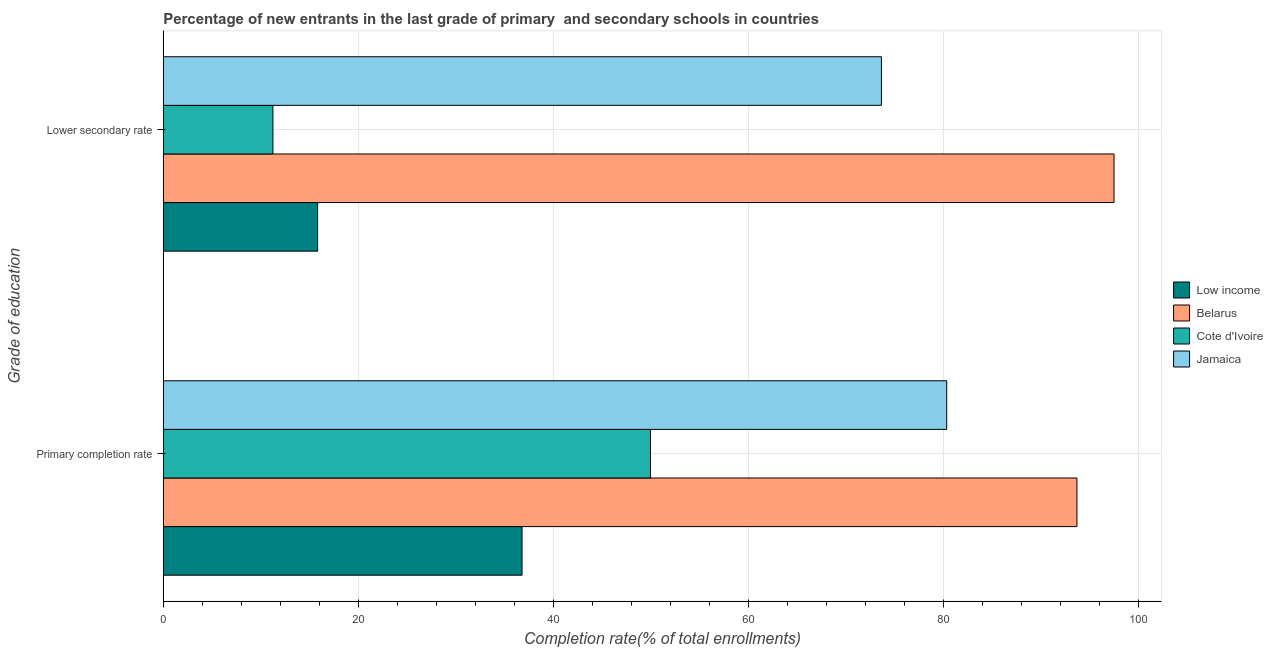Are the number of bars on each tick of the Y-axis equal?
Your response must be concise. Yes. How many bars are there on the 1st tick from the bottom?
Provide a succinct answer. 4. What is the label of the 1st group of bars from the top?
Your answer should be compact. Lower secondary rate. What is the completion rate in primary schools in Low income?
Keep it short and to the point. 36.77. Across all countries, what is the maximum completion rate in primary schools?
Your response must be concise. 93.64. Across all countries, what is the minimum completion rate in primary schools?
Keep it short and to the point. 36.77. In which country was the completion rate in primary schools maximum?
Your answer should be compact. Belarus. In which country was the completion rate in primary schools minimum?
Give a very brief answer. Low income. What is the total completion rate in primary schools in the graph?
Offer a terse response. 260.65. What is the difference between the completion rate in secondary schools in Belarus and that in Cote d'Ivoire?
Your answer should be compact. 86.21. What is the difference between the completion rate in primary schools in Cote d'Ivoire and the completion rate in secondary schools in Jamaica?
Provide a short and direct response. -23.67. What is the average completion rate in primary schools per country?
Give a very brief answer. 65.16. What is the difference between the completion rate in secondary schools and completion rate in primary schools in Jamaica?
Your answer should be very brief. -6.69. What is the ratio of the completion rate in primary schools in Jamaica to that in Low income?
Ensure brevity in your answer.  2.18. What does the 1st bar from the top in Primary completion rate represents?
Give a very brief answer. Jamaica. What does the 2nd bar from the bottom in Lower secondary rate represents?
Make the answer very short. Belarus. How many bars are there?
Your response must be concise. 8. Are all the bars in the graph horizontal?
Your answer should be compact. Yes. Are the values on the major ticks of X-axis written in scientific E-notation?
Offer a terse response. No. Does the graph contain grids?
Provide a short and direct response. Yes. Where does the legend appear in the graph?
Provide a succinct answer. Center right. How many legend labels are there?
Give a very brief answer. 4. What is the title of the graph?
Your answer should be compact. Percentage of new entrants in the last grade of primary  and secondary schools in countries. What is the label or title of the X-axis?
Ensure brevity in your answer.  Completion rate(% of total enrollments). What is the label or title of the Y-axis?
Keep it short and to the point. Grade of education. What is the Completion rate(% of total enrollments) of Low income in Primary completion rate?
Your answer should be very brief. 36.77. What is the Completion rate(% of total enrollments) of Belarus in Primary completion rate?
Your answer should be very brief. 93.64. What is the Completion rate(% of total enrollments) in Cote d'Ivoire in Primary completion rate?
Provide a succinct answer. 49.94. What is the Completion rate(% of total enrollments) of Jamaica in Primary completion rate?
Give a very brief answer. 80.3. What is the Completion rate(% of total enrollments) in Low income in Lower secondary rate?
Keep it short and to the point. 15.82. What is the Completion rate(% of total enrollments) in Belarus in Lower secondary rate?
Provide a succinct answer. 97.45. What is the Completion rate(% of total enrollments) of Cote d'Ivoire in Lower secondary rate?
Ensure brevity in your answer.  11.24. What is the Completion rate(% of total enrollments) in Jamaica in Lower secondary rate?
Provide a short and direct response. 73.6. Across all Grade of education, what is the maximum Completion rate(% of total enrollments) in Low income?
Keep it short and to the point. 36.77. Across all Grade of education, what is the maximum Completion rate(% of total enrollments) in Belarus?
Your answer should be very brief. 97.45. Across all Grade of education, what is the maximum Completion rate(% of total enrollments) in Cote d'Ivoire?
Ensure brevity in your answer.  49.94. Across all Grade of education, what is the maximum Completion rate(% of total enrollments) in Jamaica?
Your response must be concise. 80.3. Across all Grade of education, what is the minimum Completion rate(% of total enrollments) of Low income?
Your answer should be very brief. 15.82. Across all Grade of education, what is the minimum Completion rate(% of total enrollments) of Belarus?
Keep it short and to the point. 93.64. Across all Grade of education, what is the minimum Completion rate(% of total enrollments) in Cote d'Ivoire?
Your response must be concise. 11.24. Across all Grade of education, what is the minimum Completion rate(% of total enrollments) in Jamaica?
Ensure brevity in your answer.  73.6. What is the total Completion rate(% of total enrollments) in Low income in the graph?
Give a very brief answer. 52.59. What is the total Completion rate(% of total enrollments) of Belarus in the graph?
Your response must be concise. 191.09. What is the total Completion rate(% of total enrollments) of Cote d'Ivoire in the graph?
Provide a succinct answer. 61.17. What is the total Completion rate(% of total enrollments) of Jamaica in the graph?
Offer a terse response. 153.9. What is the difference between the Completion rate(% of total enrollments) of Low income in Primary completion rate and that in Lower secondary rate?
Offer a very short reply. 20.95. What is the difference between the Completion rate(% of total enrollments) of Belarus in Primary completion rate and that in Lower secondary rate?
Offer a very short reply. -3.8. What is the difference between the Completion rate(% of total enrollments) of Cote d'Ivoire in Primary completion rate and that in Lower secondary rate?
Your response must be concise. 38.7. What is the difference between the Completion rate(% of total enrollments) in Jamaica in Primary completion rate and that in Lower secondary rate?
Offer a terse response. 6.69. What is the difference between the Completion rate(% of total enrollments) in Low income in Primary completion rate and the Completion rate(% of total enrollments) in Belarus in Lower secondary rate?
Ensure brevity in your answer.  -60.68. What is the difference between the Completion rate(% of total enrollments) in Low income in Primary completion rate and the Completion rate(% of total enrollments) in Cote d'Ivoire in Lower secondary rate?
Offer a very short reply. 25.53. What is the difference between the Completion rate(% of total enrollments) of Low income in Primary completion rate and the Completion rate(% of total enrollments) of Jamaica in Lower secondary rate?
Ensure brevity in your answer.  -36.83. What is the difference between the Completion rate(% of total enrollments) of Belarus in Primary completion rate and the Completion rate(% of total enrollments) of Cote d'Ivoire in Lower secondary rate?
Provide a short and direct response. 82.41. What is the difference between the Completion rate(% of total enrollments) of Belarus in Primary completion rate and the Completion rate(% of total enrollments) of Jamaica in Lower secondary rate?
Make the answer very short. 20.04. What is the difference between the Completion rate(% of total enrollments) in Cote d'Ivoire in Primary completion rate and the Completion rate(% of total enrollments) in Jamaica in Lower secondary rate?
Offer a terse response. -23.67. What is the average Completion rate(% of total enrollments) in Low income per Grade of education?
Keep it short and to the point. 26.29. What is the average Completion rate(% of total enrollments) in Belarus per Grade of education?
Your answer should be very brief. 95.55. What is the average Completion rate(% of total enrollments) in Cote d'Ivoire per Grade of education?
Offer a terse response. 30.59. What is the average Completion rate(% of total enrollments) in Jamaica per Grade of education?
Make the answer very short. 76.95. What is the difference between the Completion rate(% of total enrollments) in Low income and Completion rate(% of total enrollments) in Belarus in Primary completion rate?
Your answer should be compact. -56.87. What is the difference between the Completion rate(% of total enrollments) of Low income and Completion rate(% of total enrollments) of Cote d'Ivoire in Primary completion rate?
Offer a terse response. -13.16. What is the difference between the Completion rate(% of total enrollments) in Low income and Completion rate(% of total enrollments) in Jamaica in Primary completion rate?
Your answer should be compact. -43.53. What is the difference between the Completion rate(% of total enrollments) of Belarus and Completion rate(% of total enrollments) of Cote d'Ivoire in Primary completion rate?
Give a very brief answer. 43.71. What is the difference between the Completion rate(% of total enrollments) of Belarus and Completion rate(% of total enrollments) of Jamaica in Primary completion rate?
Provide a short and direct response. 13.35. What is the difference between the Completion rate(% of total enrollments) in Cote d'Ivoire and Completion rate(% of total enrollments) in Jamaica in Primary completion rate?
Offer a very short reply. -30.36. What is the difference between the Completion rate(% of total enrollments) in Low income and Completion rate(% of total enrollments) in Belarus in Lower secondary rate?
Offer a very short reply. -81.63. What is the difference between the Completion rate(% of total enrollments) of Low income and Completion rate(% of total enrollments) of Cote d'Ivoire in Lower secondary rate?
Provide a succinct answer. 4.58. What is the difference between the Completion rate(% of total enrollments) of Low income and Completion rate(% of total enrollments) of Jamaica in Lower secondary rate?
Make the answer very short. -57.79. What is the difference between the Completion rate(% of total enrollments) of Belarus and Completion rate(% of total enrollments) of Cote d'Ivoire in Lower secondary rate?
Make the answer very short. 86.21. What is the difference between the Completion rate(% of total enrollments) in Belarus and Completion rate(% of total enrollments) in Jamaica in Lower secondary rate?
Make the answer very short. 23.84. What is the difference between the Completion rate(% of total enrollments) of Cote d'Ivoire and Completion rate(% of total enrollments) of Jamaica in Lower secondary rate?
Your answer should be very brief. -62.37. What is the ratio of the Completion rate(% of total enrollments) of Low income in Primary completion rate to that in Lower secondary rate?
Provide a succinct answer. 2.32. What is the ratio of the Completion rate(% of total enrollments) of Cote d'Ivoire in Primary completion rate to that in Lower secondary rate?
Your response must be concise. 4.44. What is the ratio of the Completion rate(% of total enrollments) in Jamaica in Primary completion rate to that in Lower secondary rate?
Provide a succinct answer. 1.09. What is the difference between the highest and the second highest Completion rate(% of total enrollments) of Low income?
Offer a very short reply. 20.95. What is the difference between the highest and the second highest Completion rate(% of total enrollments) in Belarus?
Your answer should be compact. 3.8. What is the difference between the highest and the second highest Completion rate(% of total enrollments) of Cote d'Ivoire?
Your answer should be very brief. 38.7. What is the difference between the highest and the second highest Completion rate(% of total enrollments) in Jamaica?
Keep it short and to the point. 6.69. What is the difference between the highest and the lowest Completion rate(% of total enrollments) of Low income?
Provide a succinct answer. 20.95. What is the difference between the highest and the lowest Completion rate(% of total enrollments) of Belarus?
Offer a terse response. 3.8. What is the difference between the highest and the lowest Completion rate(% of total enrollments) of Cote d'Ivoire?
Offer a terse response. 38.7. What is the difference between the highest and the lowest Completion rate(% of total enrollments) in Jamaica?
Keep it short and to the point. 6.69. 